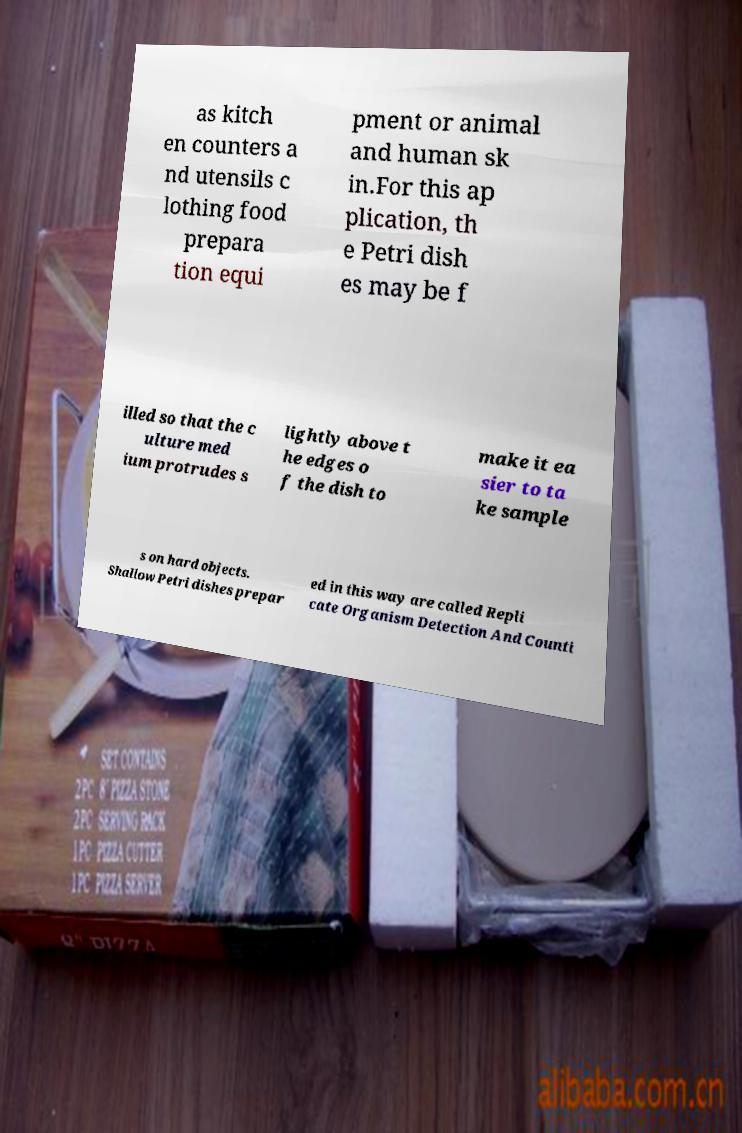Could you extract and type out the text from this image? as kitch en counters a nd utensils c lothing food prepara tion equi pment or animal and human sk in.For this ap plication, th e Petri dish es may be f illed so that the c ulture med ium protrudes s lightly above t he edges o f the dish to make it ea sier to ta ke sample s on hard objects. Shallow Petri dishes prepar ed in this way are called Repli cate Organism Detection And Counti 